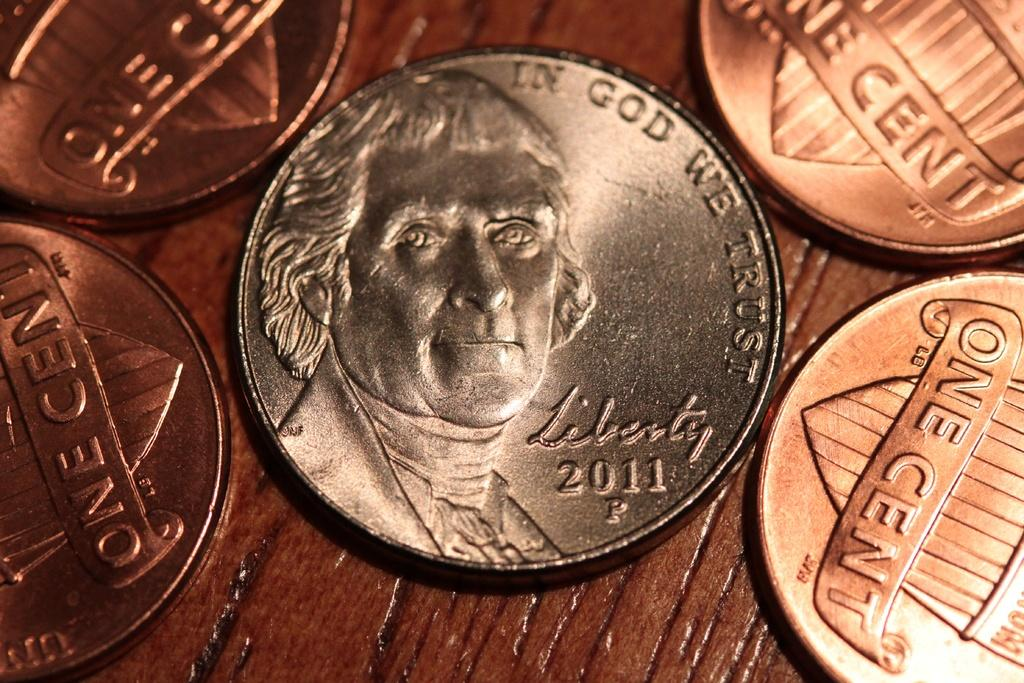<image>
Share a concise interpretation of the image provided. A penny that says on the back one cent 